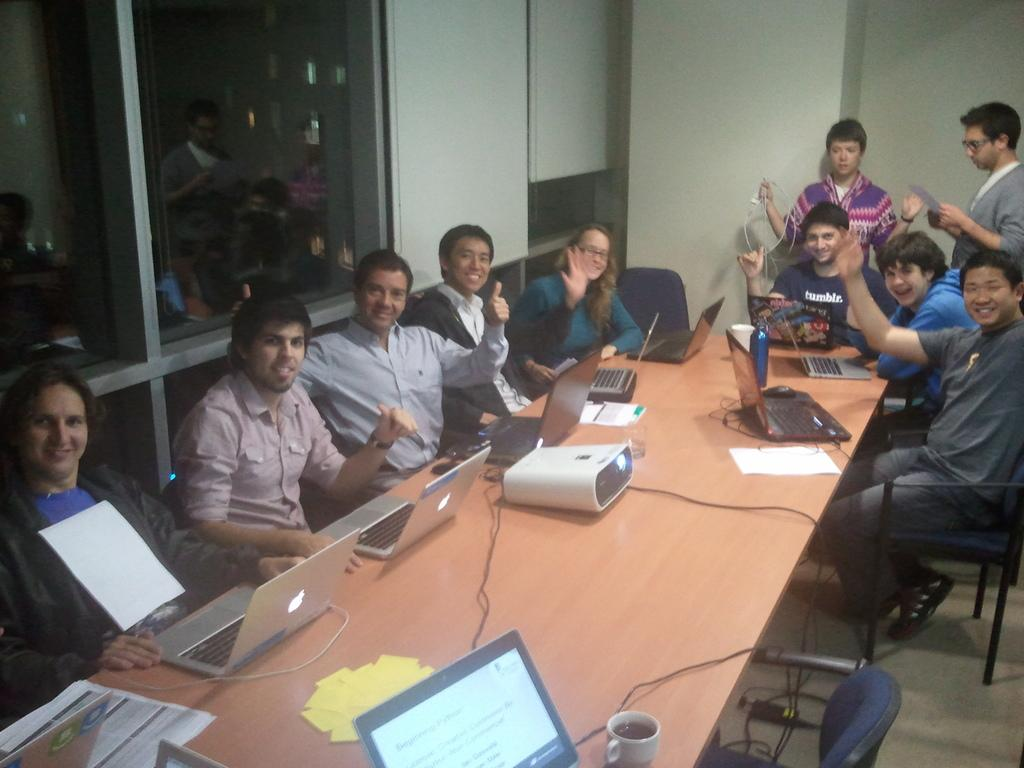How many people are in the image? There are people in the image. What type of furniture is present in the image? There are chairs and a table in the image. What electronic devices can be seen in the image? There are laptops and a projector in the image. What type of container is visible in the image? There is a bottle in the image. What type of written material is present in the image? There are papers in the image. What type of architectural feature is present in the image? There are windows in the image. What type of objects are present in the image? There are objects in the image. What are two people doing in the image? Two people are standing and holding objects. What type of trouble is the cook causing with the knife in the image? There is no cook or knife present in the image. How does the cook use the knife to prepare the meal in the image? There is no cook or knife present in the image, so it is not possible to answer this question. 